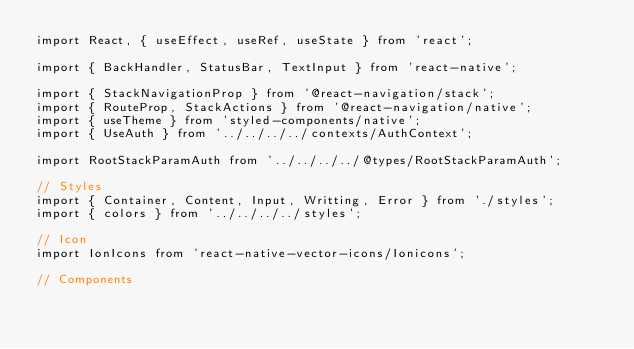Convert code to text. <code><loc_0><loc_0><loc_500><loc_500><_TypeScript_>import React, { useEffect, useRef, useState } from 'react';

import { BackHandler, StatusBar, TextInput } from 'react-native';

import { StackNavigationProp } from '@react-navigation/stack';
import { RouteProp, StackActions } from '@react-navigation/native';
import { useTheme } from 'styled-components/native';
import { UseAuth } from '../../../../contexts/AuthContext';

import RootStackParamAuth from '../../../../@types/RootStackParamAuth';

// Styles
import { Container, Content, Input, Writting, Error } from './styles';
import { colors } from '../../../../styles';

// Icon
import IonIcons from 'react-native-vector-icons/Ionicons';

// Components</code> 